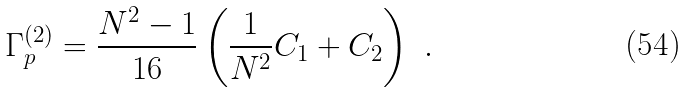<formula> <loc_0><loc_0><loc_500><loc_500>\Gamma _ { p } ^ { ( 2 ) } = \frac { N ^ { 2 } - 1 } { 1 6 } \left ( \frac { 1 } { N ^ { 2 } } C _ { 1 } + C _ { 2 } \right ) \ .</formula> 